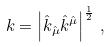<formula> <loc_0><loc_0><loc_500><loc_500>k = \left | \hat { k } _ { \hat { \mu } } \hat { k } ^ { \hat { \mu } } \right | ^ { \frac { 1 } { 2 } } \, ,</formula> 